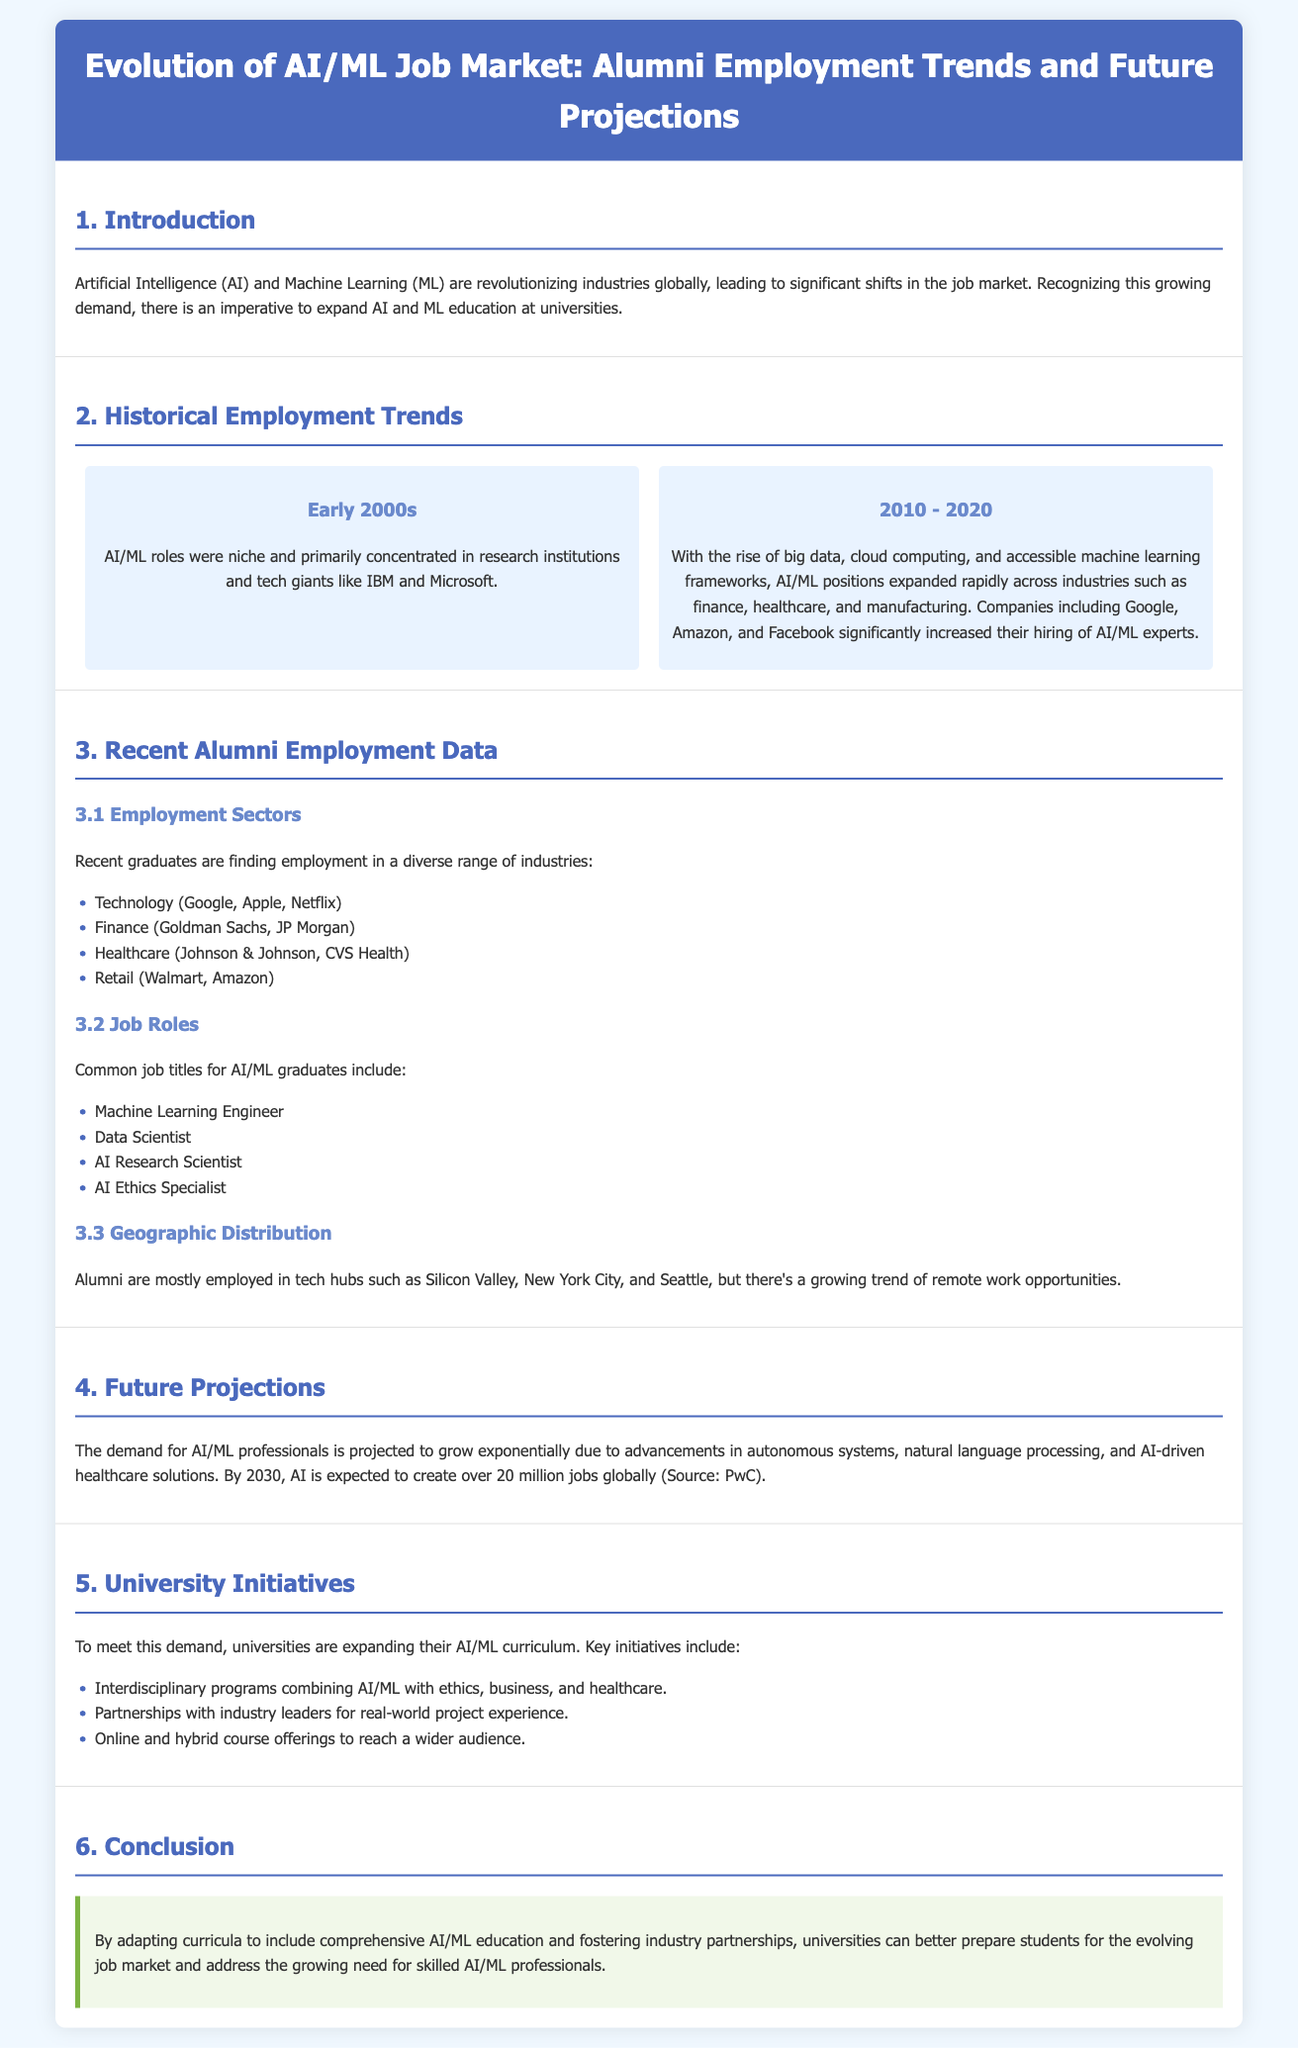What decade did AI/ML roles primarily concentrate in research institutions? The document states that AI/ML roles were primarily concentrated in research institutions in the early 2000s.
Answer: early 2000s Which companies significantly increased their hiring of AI/ML experts from 2010 to 2020? The document lists Google, Amazon, and Facebook as companies that significantly increased their hiring of AI/ML experts during that period.
Answer: Google, Amazon, Facebook What is the projected job creation for AI by 2030? According to the document, AI is expected to create over 20 million jobs globally by 2030.
Answer: 20 million What are two common job titles for AI/ML graduates? The document lists Machine Learning Engineer and Data Scientist as common job titles for AI/ML graduates.
Answer: Machine Learning Engineer, Data Scientist What is one key initiative mentioned for university expansion of AI/ML education? The document mentions interdisciplinary programs combining AI/ML with ethics, business, and healthcare as a key initiative for curriculum expansion.
Answer: Interdisciplinary programs How have alumni employment sectors changed in recent years? The document describes that recent graduates are finding employment in diverse industries, comparing the past to the present and indicating a broader range.
Answer: Diverse industries In which geographic locations are most alumni employed? The document mentions that alumni are mostly employed in tech hubs such as Silicon Valley, New York City, and Seattle.
Answer: Silicon Valley, New York City, Seattle What type of document is this? The document presents historical trends, recent data, and future projections related to the AI/ML job market.
Answer: Hierarchical infographic 